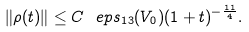<formula> <loc_0><loc_0><loc_500><loc_500>\| \rho ( t ) \| \leq C \ e p s _ { 1 3 } ( V _ { 0 } ) ( 1 + t ) ^ { - \frac { 1 1 } { 4 } } .</formula> 